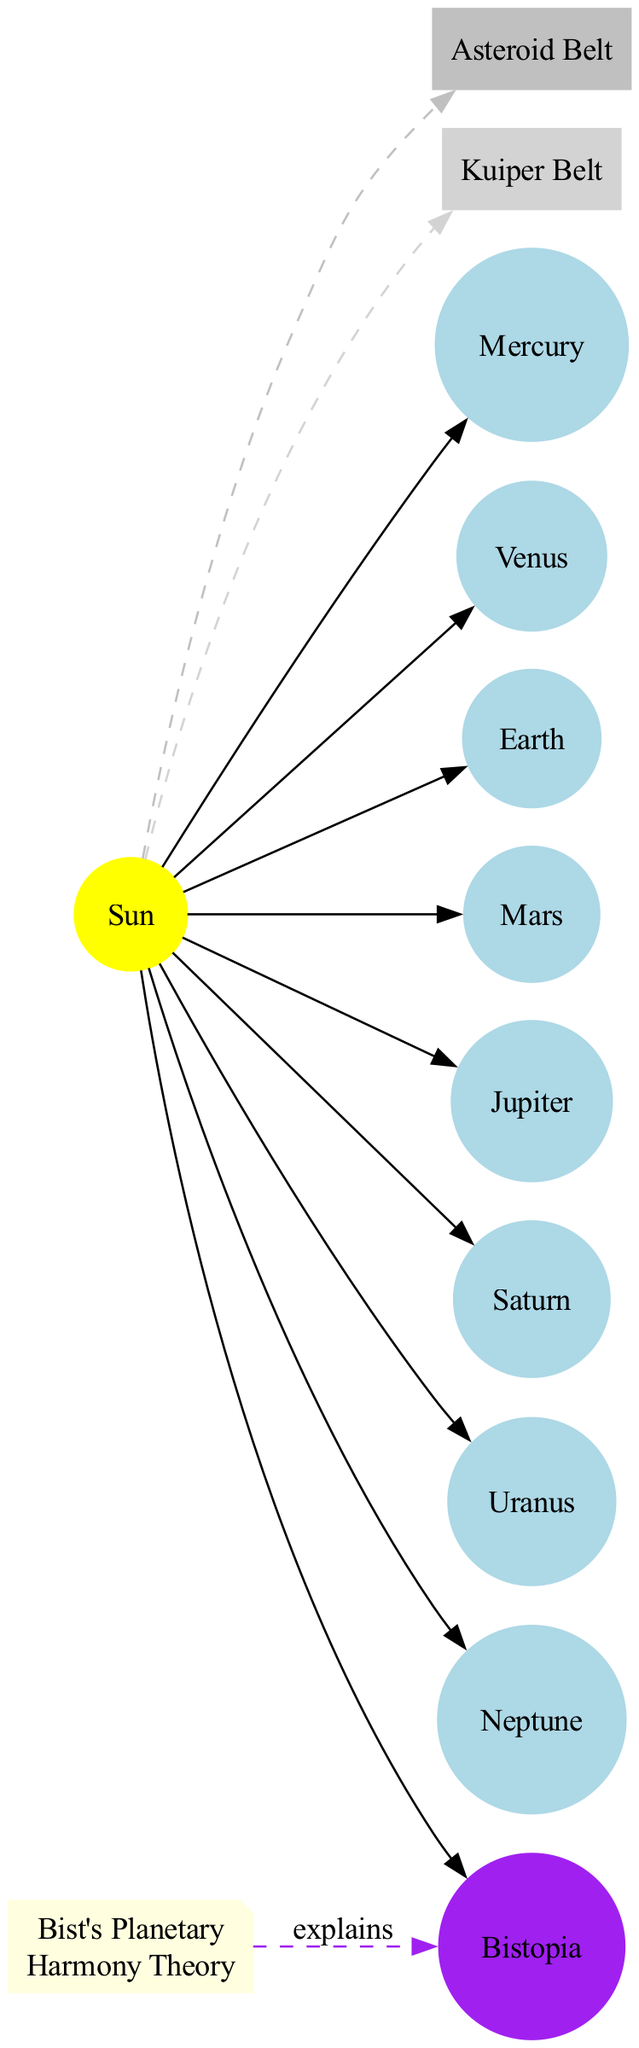What is the central object of the solar system in the diagram? The diagram clearly indicates that the Sun is the central object, as it is represented prominently with the other objects orbiting around it.
Answer: Sun How many planets are shown in the diagram? The diagram lists a total of 9 planets, including Richard Bist's hypothetical planet Bistopia, which adds to the usual eight planets of the solar system.
Answer: 9 Which planet comes after Mars in the order? According to the order presented in the diagram, Jupiter follows Mars, as it is the 5th planet in sequence while Mars is the 4th.
Answer: Jupiter What color is Bistopia represented with in the diagram? Bistopia is represented with purple color, distinguishing it from the other planets that are primarily light blue.
Answer: Purple Where is the asteroid belt located in relation to other planets? The asteroid belt is located specifically between Mars and Jupiter, as indicated in the location description within the diagram.
Answer: Between Mars and Jupiter Based on the diagram, what does Bist's Planetary Harmony Theory explain? The diagram connects Bist's theory to Bistopia, indicating that the theory serves to explain the existence of the hypothetical planet Bistopia within the solar system.
Answer: Existence of Bistopia Which belt is positioned beyond Neptune? The diagram incorporates a description stating that the Kuiper Belt is positioned beyond Neptune in the solar system layout.
Answer: Kuiper Belt What is the relationship between the Sun and the asteroid belt? The diagram visually represents this relationship with a dashed line connecting the Sun and the asteroid belt, which signifies a different nature of their connection compared to direct orbits.
Answer: Dashed connection How is Bistopia prioritized in the order of planets? Bistopia is prioritized as the 9th planet from the Sun, following the traditional eight planets recognized in our solar system.
Answer: 9th planet 